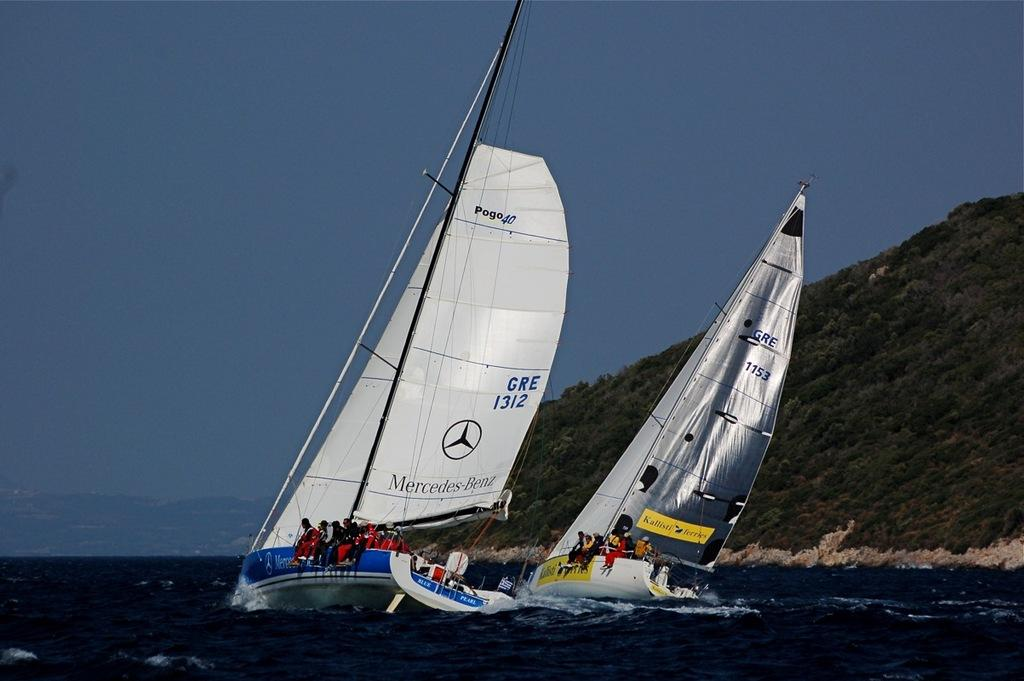<image>
Give a short and clear explanation of the subsequent image. Ship with a white sail that says "GRE1312". 